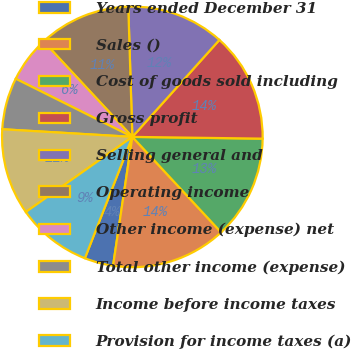Convert chart to OTSL. <chart><loc_0><loc_0><loc_500><loc_500><pie_chart><fcel>Years ended December 31<fcel>Sales ()<fcel>Cost of goods sold including<fcel>Gross profit<fcel>Selling general and<fcel>Operating income<fcel>Other income (expense) net<fcel>Total other income (expense)<fcel>Income before income taxes<fcel>Provision for income taxes (a)<nl><fcel>3.57%<fcel>14.29%<fcel>12.86%<fcel>13.57%<fcel>12.14%<fcel>11.43%<fcel>5.71%<fcel>6.43%<fcel>10.71%<fcel>9.29%<nl></chart> 